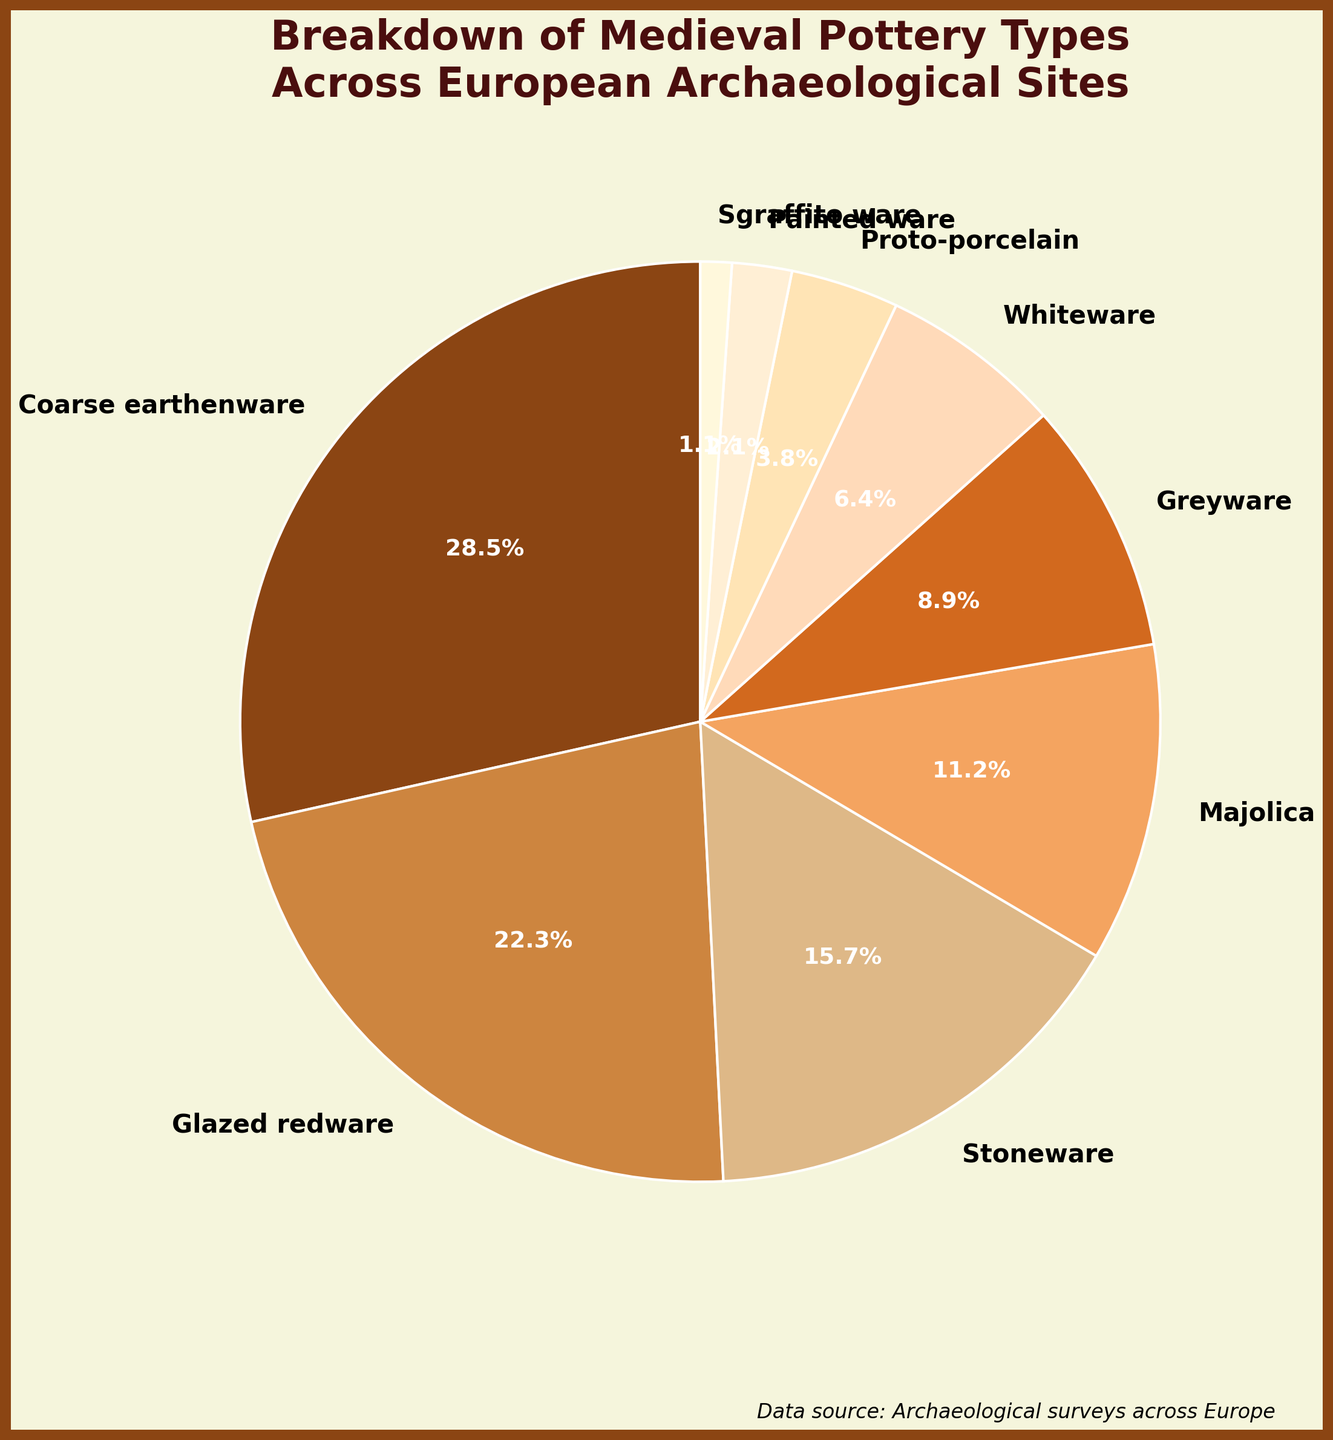What's the most common type of pottery discovered across European archaeological sites? The pie chart shows different types of pottery with their corresponding percentages. The most significant slice, representing 28.5%, is labeled "Coarse earthenware", making it the most common type.
Answer: Coarse earthenware Which pottery type has nearly one-third the frequency of Coarse earthenware? Coarse earthenware accounts for 28.5%. One-third of that is approximately 9.5%. The type with a percentage close to 9.5% is "Greyware", which has 8.9%.
Answer: Greyware How do the percentages of Glazed redware and Whiteware compare? Glazed redware accounts for 22.3%, and Whiteware accounts for 6.4%. Glazed redware has a higher percentage than Whiteware.
Answer: Glazed redware has a higher percentage What's the difference in percentage between Stoneware and Majolica? Stoneware accounts for 15.7% and Majolica for 11.2%. The difference is \(15.7 - 11.2 = 4.5\).
Answer: 4.5% Which pottery type contributes the smallest percentage to the total? The smallest slice of the pie chart is labeled "Sgraffito ware", which accounts for 1.1%.
Answer: Sgraffito ware Combine the percentages of Proto-porcelain, Painted ware, and Sgraffito ware. Does the sum exceed the percentage of Stoneware? Proto-porcelain: 3.8%, Painted ware: 2.1%, Sgraffito ware: 1.1%. The combined percentage is \(3.8 + 2.1 + 1.1 = 7.0%\), which is less than Stoneware's 15.7%.
Answer: No Are there any pottery types that have a percentage lower than 5%? If so, which ones? The types with percentages below 5% are "Proto-porcelain" (3.8%), "Painted ware" (2.1%), and "Sgraffito ware" (1.1%).
Answer: Proto-porcelain, Painted ware, Sgraffito ware What is the combined percentage of Stoneware and Greyware? Stoneware accounts for 15.7% and Greyware for 8.9%. The combined percentage is \(15.7 + 8.9 = 24.6\).
Answer: 24.6% Which type of pottery is visually represented by the slice with the darkest color? The darkest slice in the pie chart, visually distinguishable, represents "Coarse earthenware".
Answer: Coarse earthenware What proportion of the total percentage is made up by the top three pottery types? The top three types by percentage are Coarse earthenware (28.5%), Glazed redware (22.3%), and Stoneware (15.7%). Adding them together, \(28.5 + 22.3 + 15.7 = 66.5\).
Answer: 66.5% 